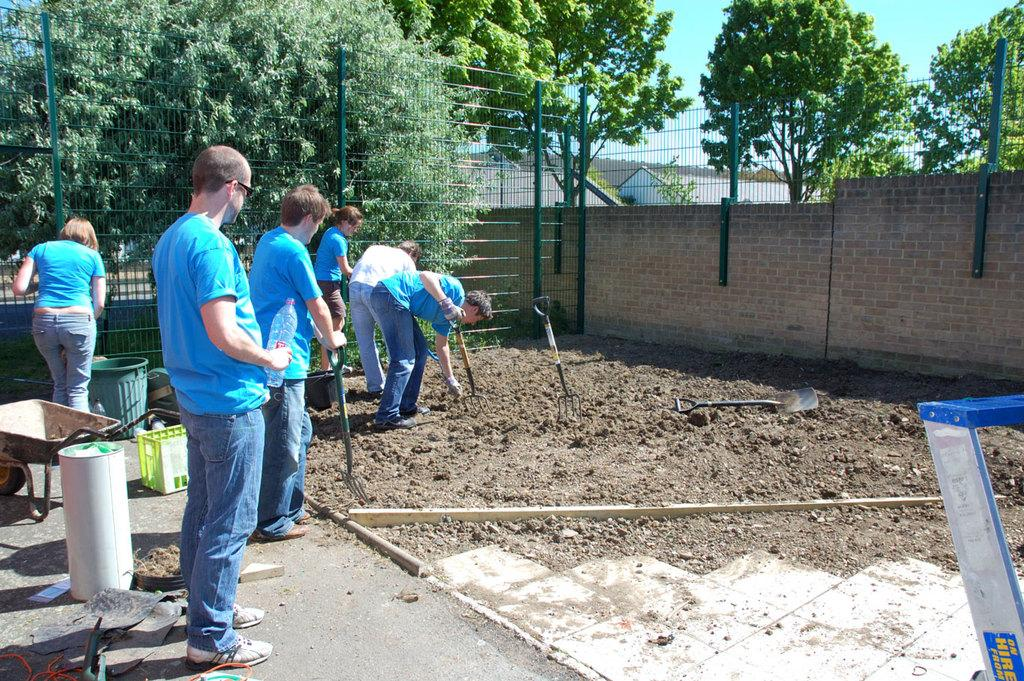What are the people in the image doing? The persons in the image are standing on the ground. What type of natural elements can be seen in the image? There are trees visible in the image. What structure is located on the right side of the image? There is a wall on the right side of the image. What type of riddle can be seen etched into the brass surface in the image? There is no brass surface or riddle present in the image. 